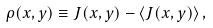Convert formula to latex. <formula><loc_0><loc_0><loc_500><loc_500>\rho ( x , y ) \equiv J ( x , y ) - \langle J ( x , y ) \rangle \, ,</formula> 